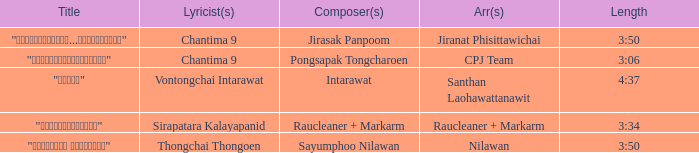Who was the composer of "ขอโทษ"? Intarawat. 